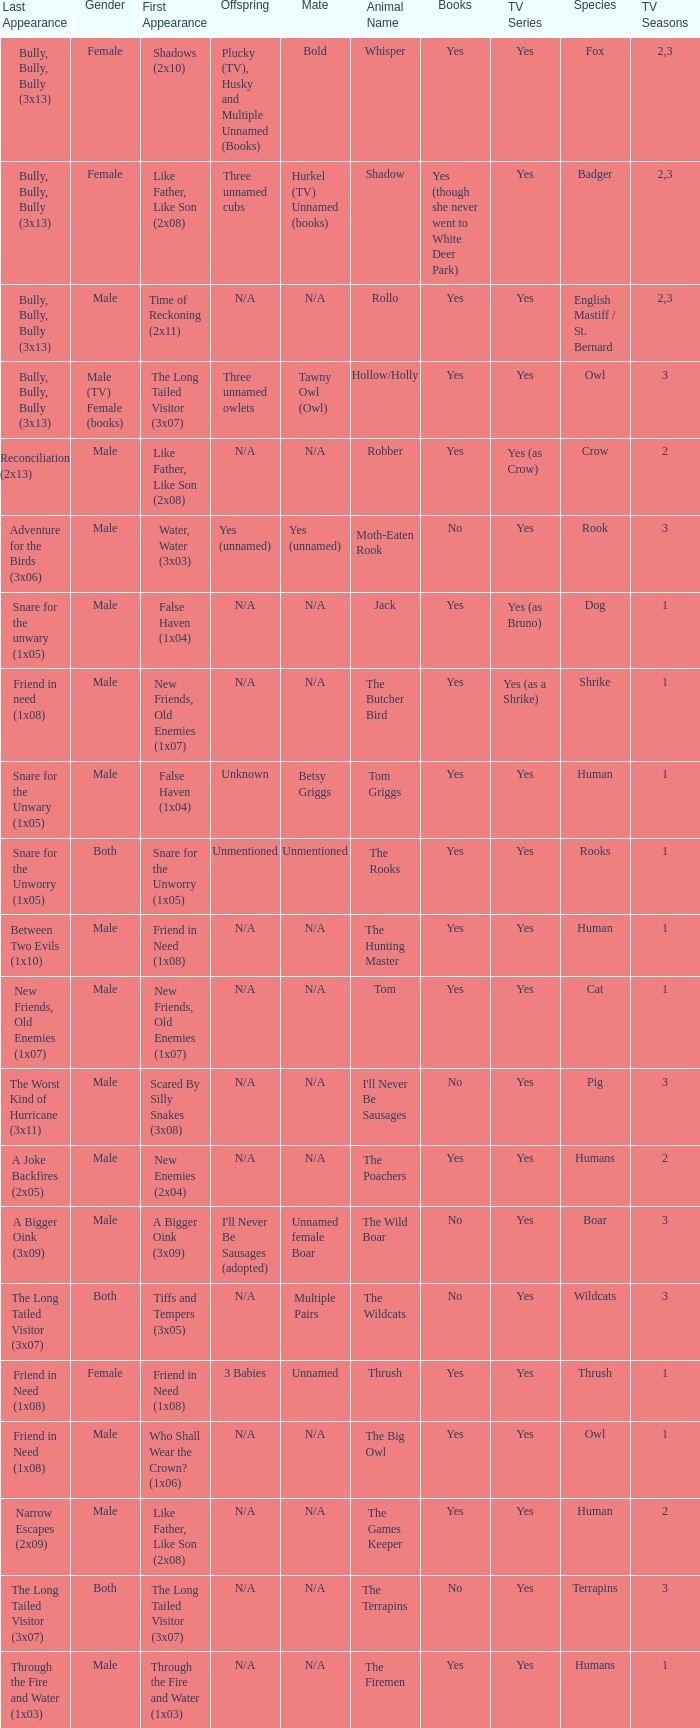What is the mate for Last Appearance of bully, bully, bully (3x13) for the animal named hollow/holly later than season 1? Tawny Owl (Owl). 